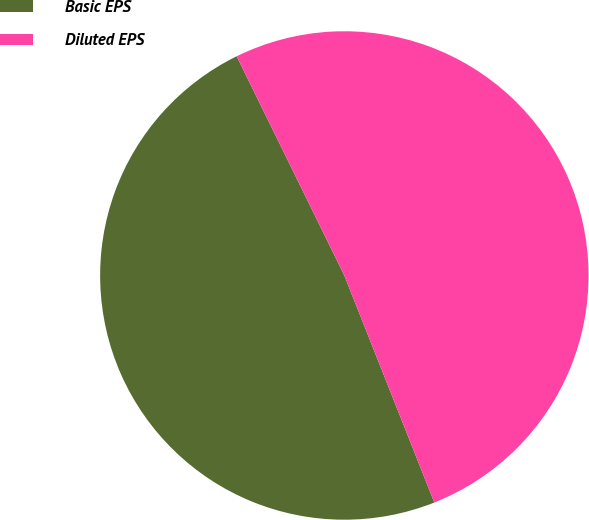<chart> <loc_0><loc_0><loc_500><loc_500><pie_chart><fcel>Basic EPS<fcel>Diluted EPS<nl><fcel>48.74%<fcel>51.26%<nl></chart> 